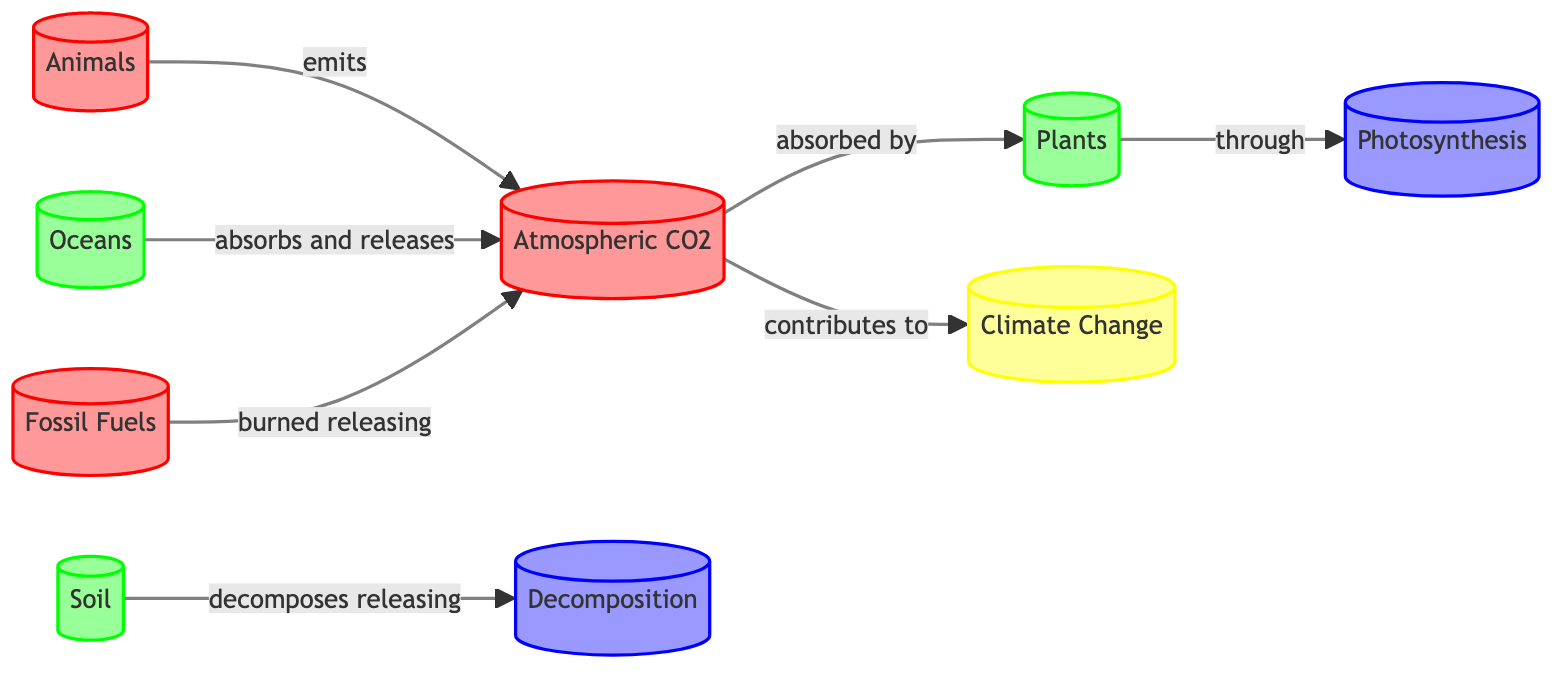What are the main sources of carbon in the diagram? The main sources of carbon in the diagram are represented by the nodes: "Atmospheric CO2," "Animals," and "Fossil Fuels." These nodes are indicated with a specific color code for sources.
Answer: Atmospheric CO2, Animals, Fossil Fuels How many sinks are represented in the diagram? The sinks in the diagram are represented by the nodes: "Plants," "Soil," and "Oceans." To find the number, count these nodes. There are three sinks in total.
Answer: 3 What process absorbs atmospheric CO2? The process that absorbs atmospheric CO2 in the diagram is "Photosynthesis." It's indicated as a process that connects "Atmospheric CO2" to "Plants."
Answer: Photosynthesis Which entity contributes to climate change? The entity contributing to climate change is "Atmospheric CO2," which is directly connected to "Climate Change" in the diagram.
Answer: Atmospheric CO2 What process is linked to decomposition? The process linked to decomposition in the diagram is simply "Decomposition." This process is shown as connecting the "Soil" node to the carbon cycle.
Answer: Decomposition How do oceans interact with atmospheric CO2? Oceans interact with atmospheric CO2 by absorbing and releasing it. The relationship is indicated by a bidirectional arrow between "Oceans" and "Atmospheric CO2."
Answer: Absorb and release What is the role of animals in the carbon cycle as per the diagram? Animals are shown to emit atmospheric CO2 in the diagram, which highlights their role in returning carbon to the atmosphere.
Answer: Emits atmospheric CO2 How many processes are indicated in the diagram? The processes indicated in the diagram are "Photosynthesis," "Decomposition," and "Fossil Fuels." Count these nodes to arrive at the total number of processes, which is three.
Answer: 3 